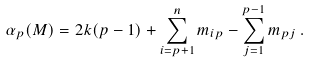<formula> <loc_0><loc_0><loc_500><loc_500>\alpha _ { p } ( M ) = 2 k ( p - 1 ) + \sum _ { i = p + 1 } ^ { n } m _ { i p } - \sum _ { j = 1 } ^ { p - 1 } m _ { p j } \, .</formula> 